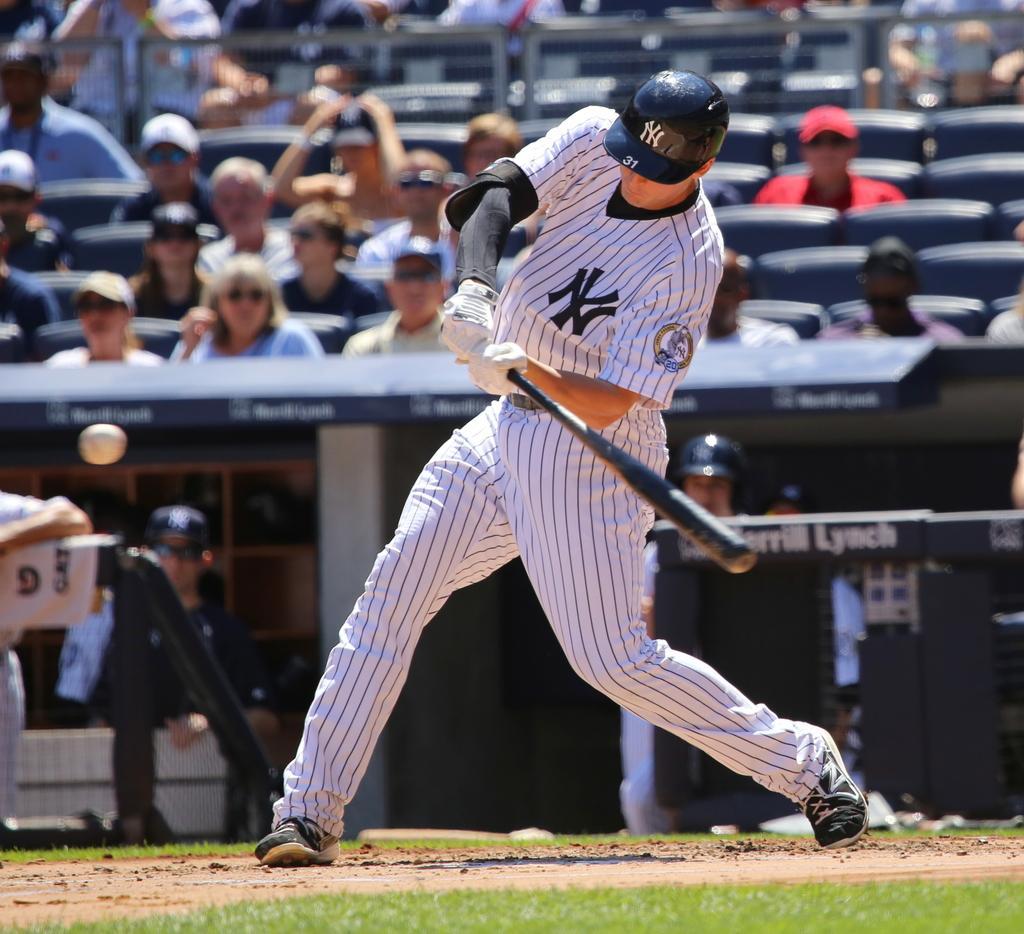Can you describe this image briefly? In this image we can see a person wearing white color dress, black color helmet playing baseball holding black color baseball stick in his hands and there is a ball and in the background of the image there are some persons sitting on chairs. 